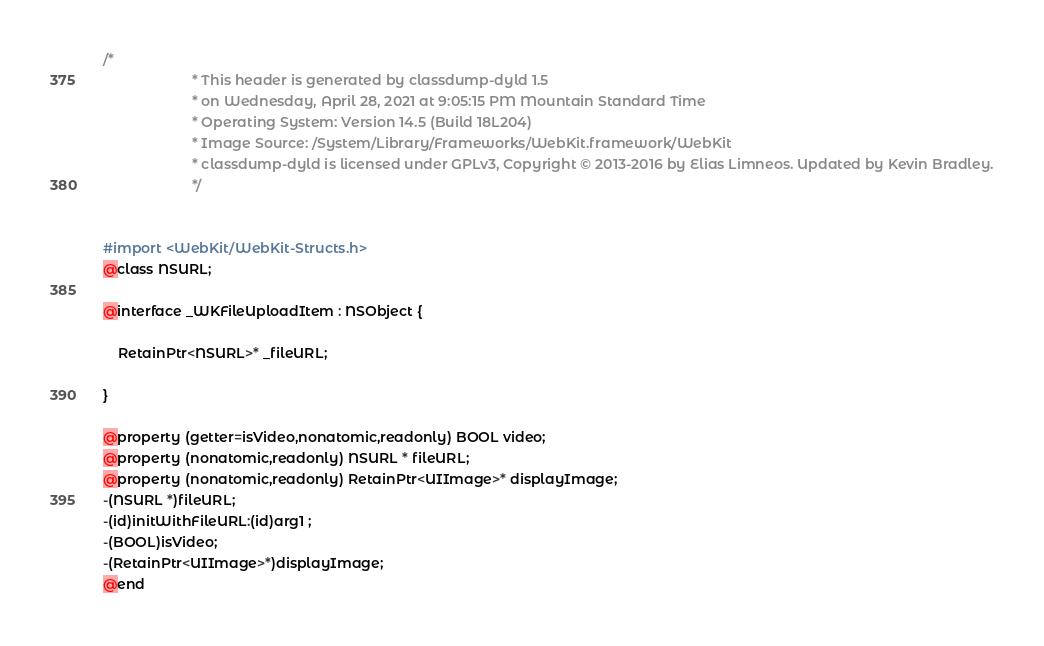Convert code to text. <code><loc_0><loc_0><loc_500><loc_500><_C_>/*
                       * This header is generated by classdump-dyld 1.5
                       * on Wednesday, April 28, 2021 at 9:05:15 PM Mountain Standard Time
                       * Operating System: Version 14.5 (Build 18L204)
                       * Image Source: /System/Library/Frameworks/WebKit.framework/WebKit
                       * classdump-dyld is licensed under GPLv3, Copyright © 2013-2016 by Elias Limneos. Updated by Kevin Bradley.
                       */


#import <WebKit/WebKit-Structs.h>
@class NSURL;

@interface _WKFileUploadItem : NSObject {

	RetainPtr<NSURL>* _fileURL;

}

@property (getter=isVideo,nonatomic,readonly) BOOL video; 
@property (nonatomic,readonly) NSURL * fileURL; 
@property (nonatomic,readonly) RetainPtr<UIImage>* displayImage; 
-(NSURL *)fileURL;
-(id)initWithFileURL:(id)arg1 ;
-(BOOL)isVideo;
-(RetainPtr<UIImage>*)displayImage;
@end

</code> 